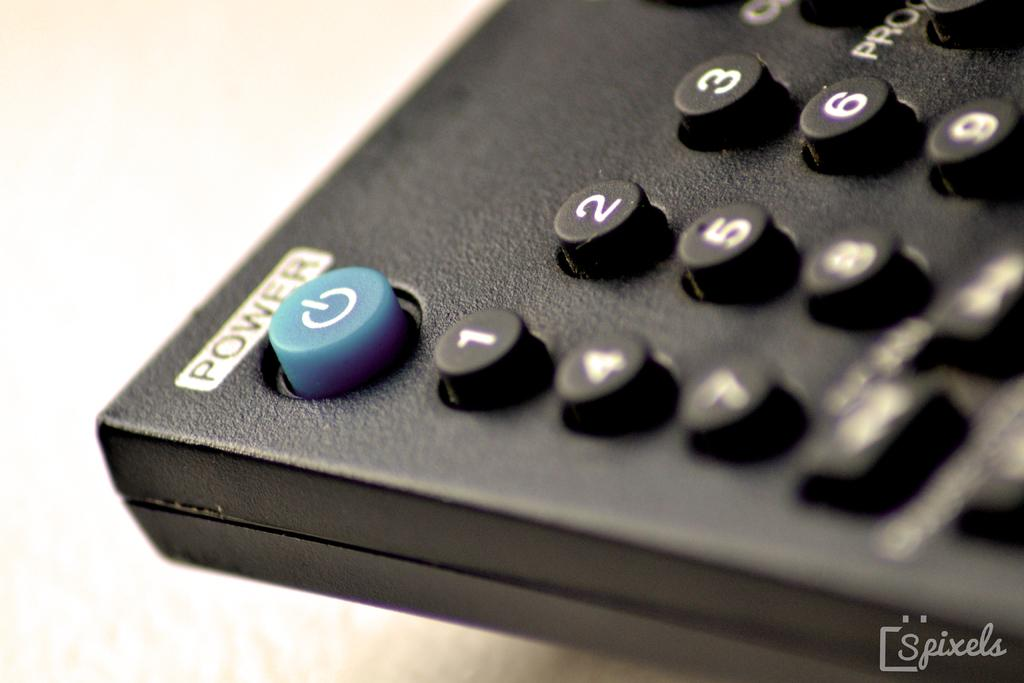<image>
Summarize the visual content of the image. A television remote control with a blue power button with the power label at the top. 